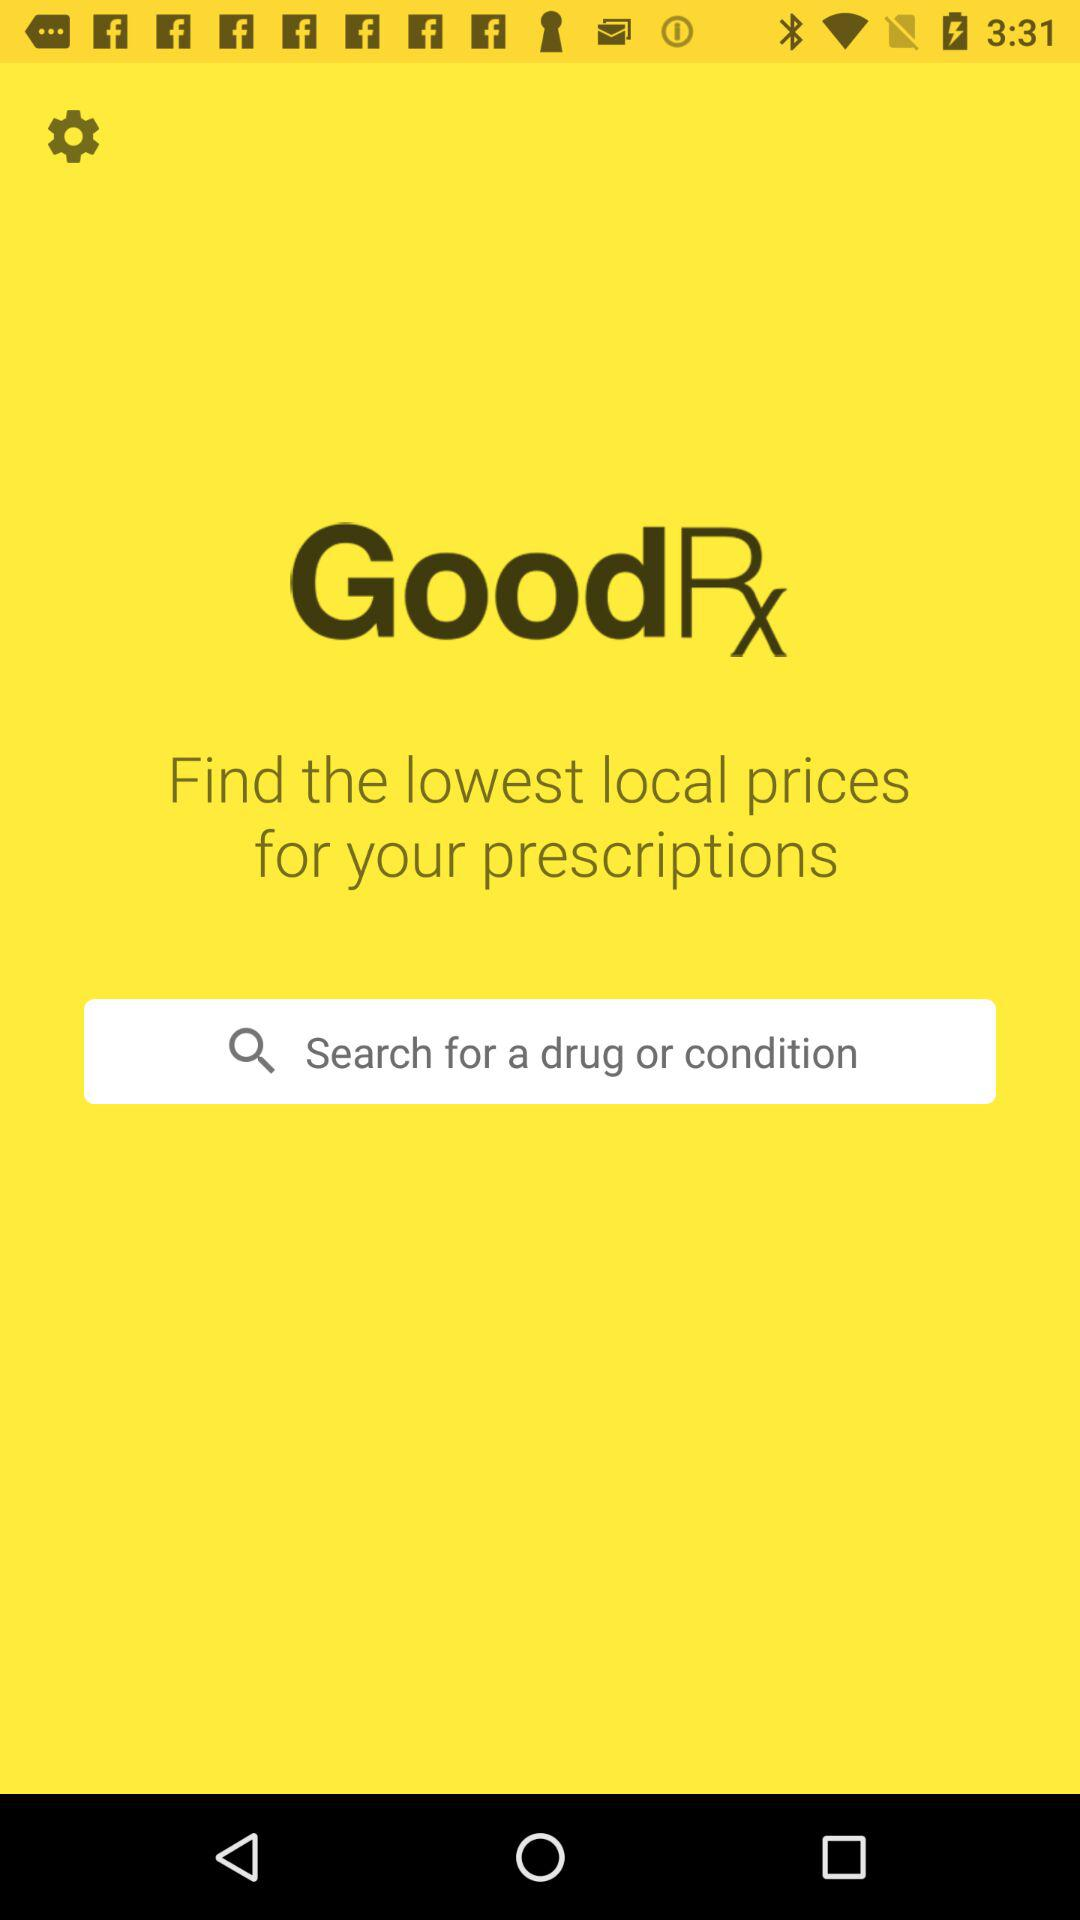What is the application name? The application name is "GoodRx". 